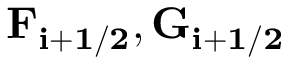Convert formula to latex. <formula><loc_0><loc_0><loc_500><loc_500>F _ { i + 1 / 2 } , G _ { i + 1 / 2 }</formula> 